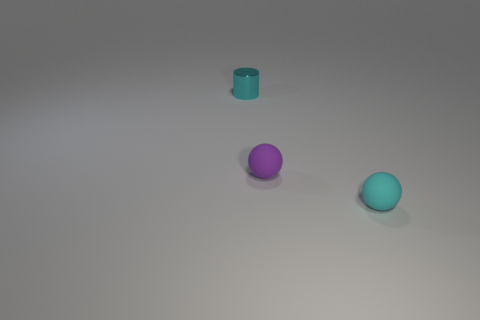Add 2 tiny purple things. How many objects exist? 5 Subtract all cyan spheres. How many spheres are left? 1 Subtract all cylinders. How many objects are left? 2 Subtract 1 balls. How many balls are left? 1 Subtract all green cubes. How many purple balls are left? 1 Subtract all tiny objects. Subtract all yellow rubber cylinders. How many objects are left? 0 Add 3 small cyan spheres. How many small cyan spheres are left? 4 Add 1 purple objects. How many purple objects exist? 2 Subtract 0 green cylinders. How many objects are left? 3 Subtract all red spheres. Subtract all red cylinders. How many spheres are left? 2 